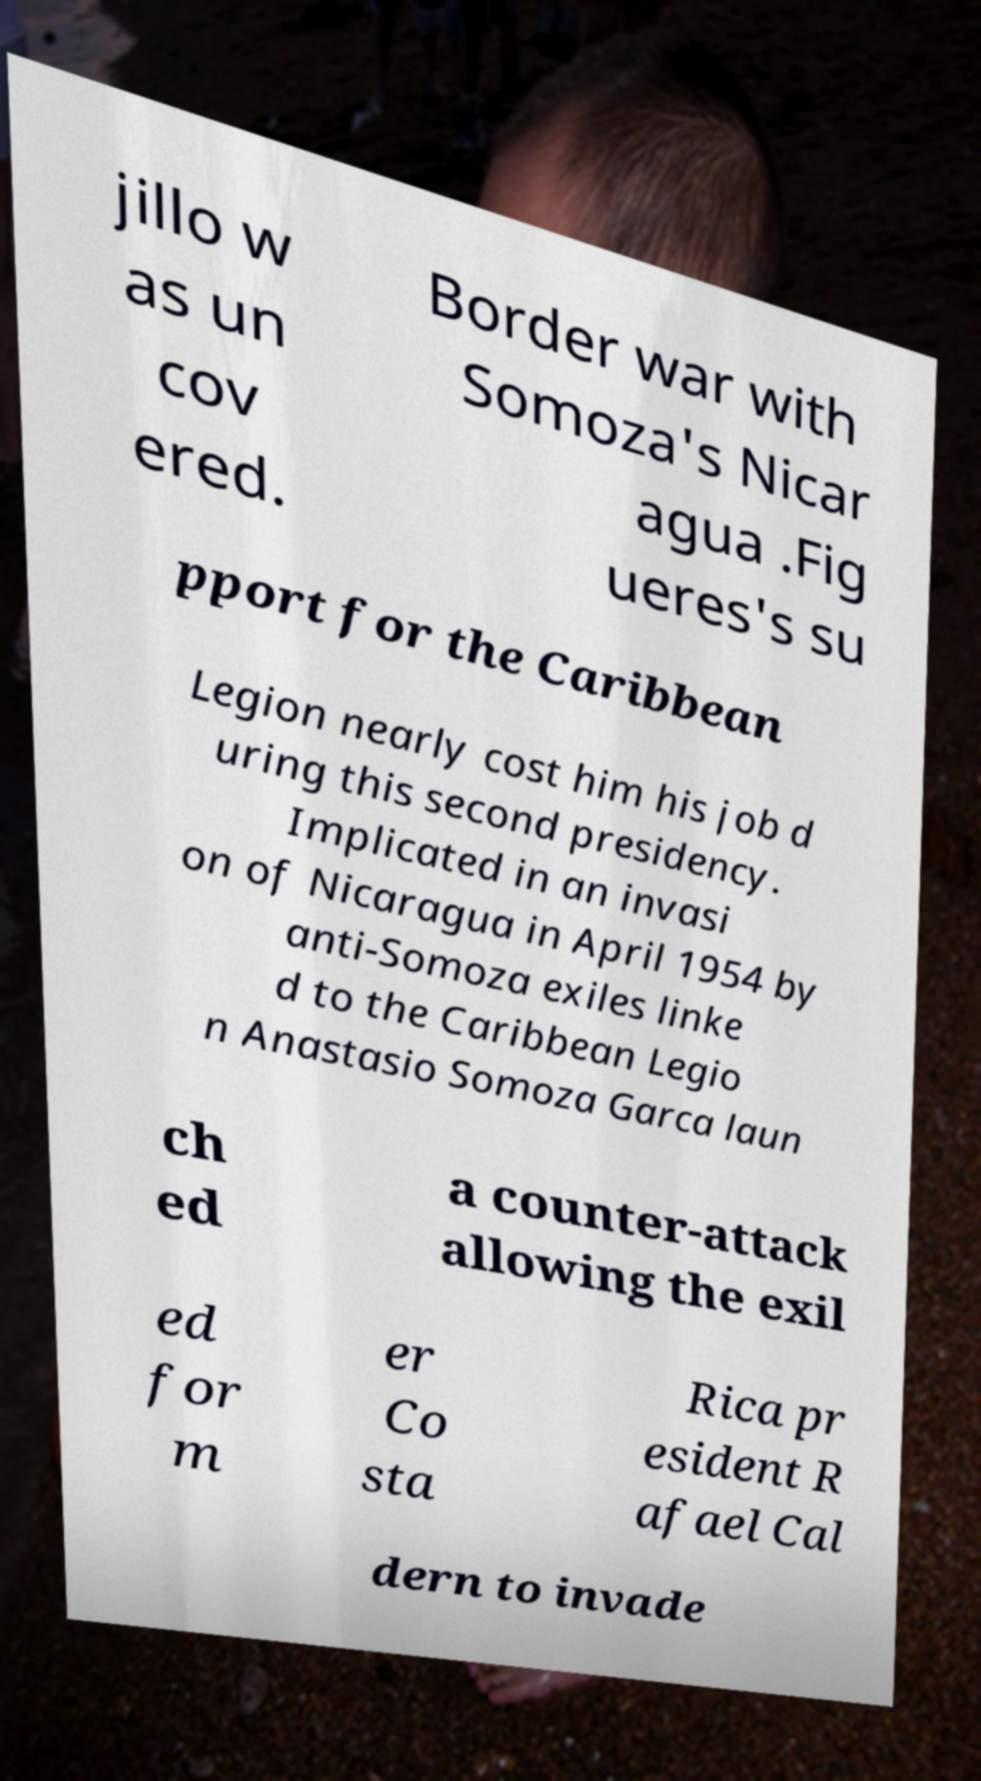Can you read and provide the text displayed in the image?This photo seems to have some interesting text. Can you extract and type it out for me? jillo w as un cov ered. Border war with Somoza's Nicar agua .Fig ueres's su pport for the Caribbean Legion nearly cost him his job d uring this second presidency. Implicated in an invasi on of Nicaragua in April 1954 by anti-Somoza exiles linke d to the Caribbean Legio n Anastasio Somoza Garca laun ch ed a counter-attack allowing the exil ed for m er Co sta Rica pr esident R afael Cal dern to invade 